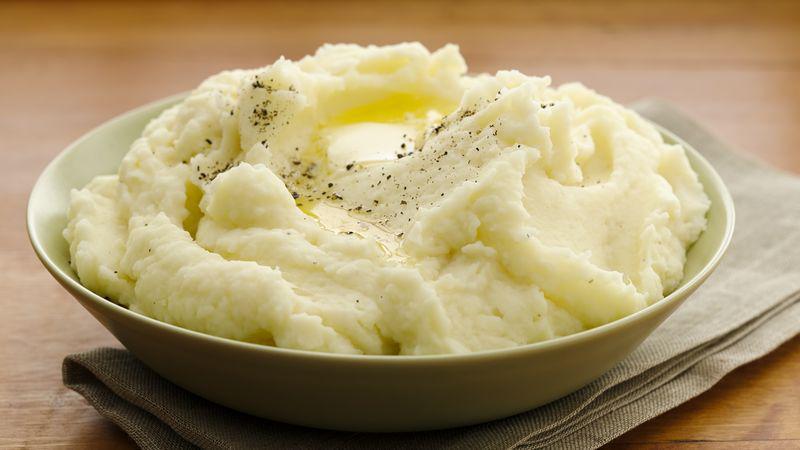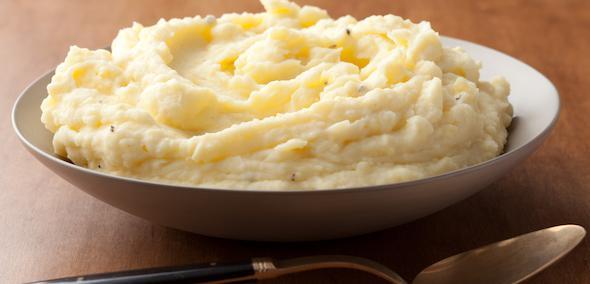The first image is the image on the left, the second image is the image on the right. Examine the images to the left and right. Is the description "A spoon is visible next to one of the dishes of food." accurate? Answer yes or no. Yes. 